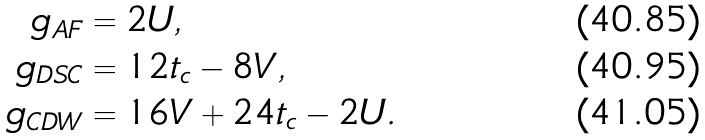Convert formula to latex. <formula><loc_0><loc_0><loc_500><loc_500>g _ { \text {AF} } & = 2 U , \\ g _ { \text {DSC} } & = 1 2 t _ { c } - 8 V , \\ g _ { \text {CDW} } & = 1 6 V + 2 4 t _ { c } - 2 U .</formula> 